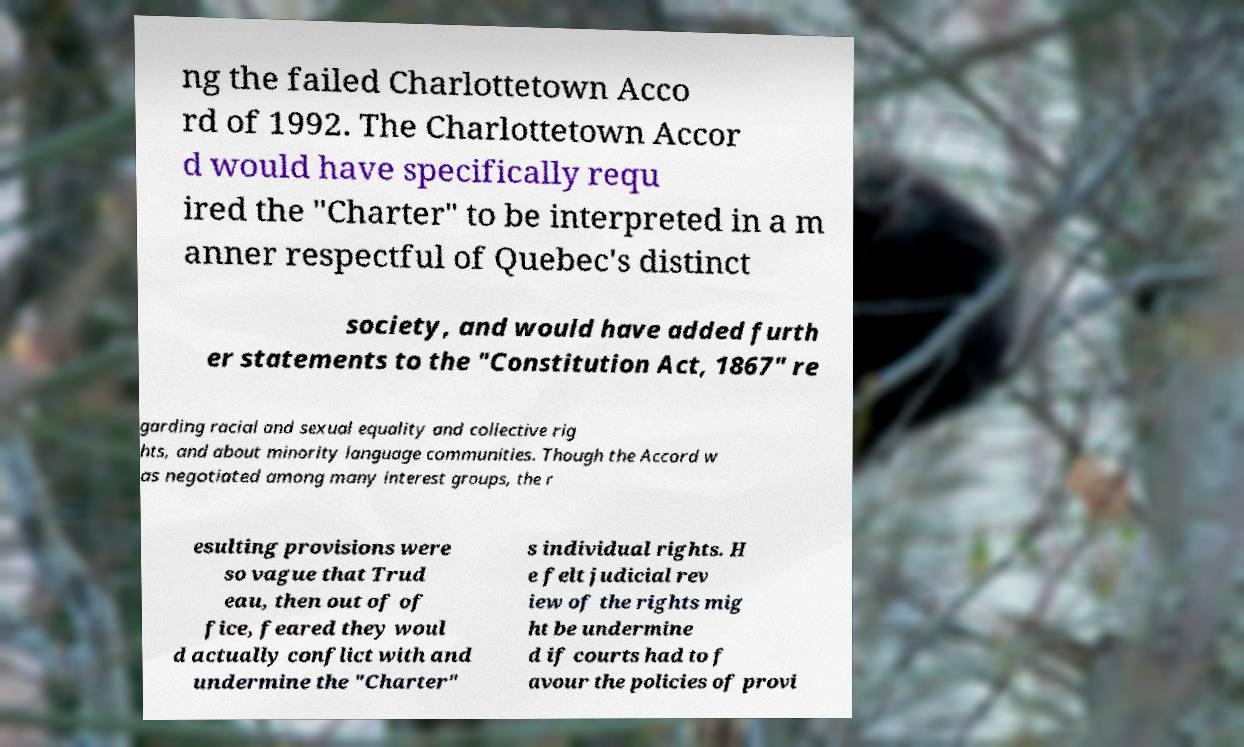Please read and relay the text visible in this image. What does it say? ng the failed Charlottetown Acco rd of 1992. The Charlottetown Accor d would have specifically requ ired the "Charter" to be interpreted in a m anner respectful of Quebec's distinct society, and would have added furth er statements to the "Constitution Act, 1867" re garding racial and sexual equality and collective rig hts, and about minority language communities. Though the Accord w as negotiated among many interest groups, the r esulting provisions were so vague that Trud eau, then out of of fice, feared they woul d actually conflict with and undermine the "Charter" s individual rights. H e felt judicial rev iew of the rights mig ht be undermine d if courts had to f avour the policies of provi 